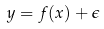<formula> <loc_0><loc_0><loc_500><loc_500>y = f ( x ) + \epsilon</formula> 